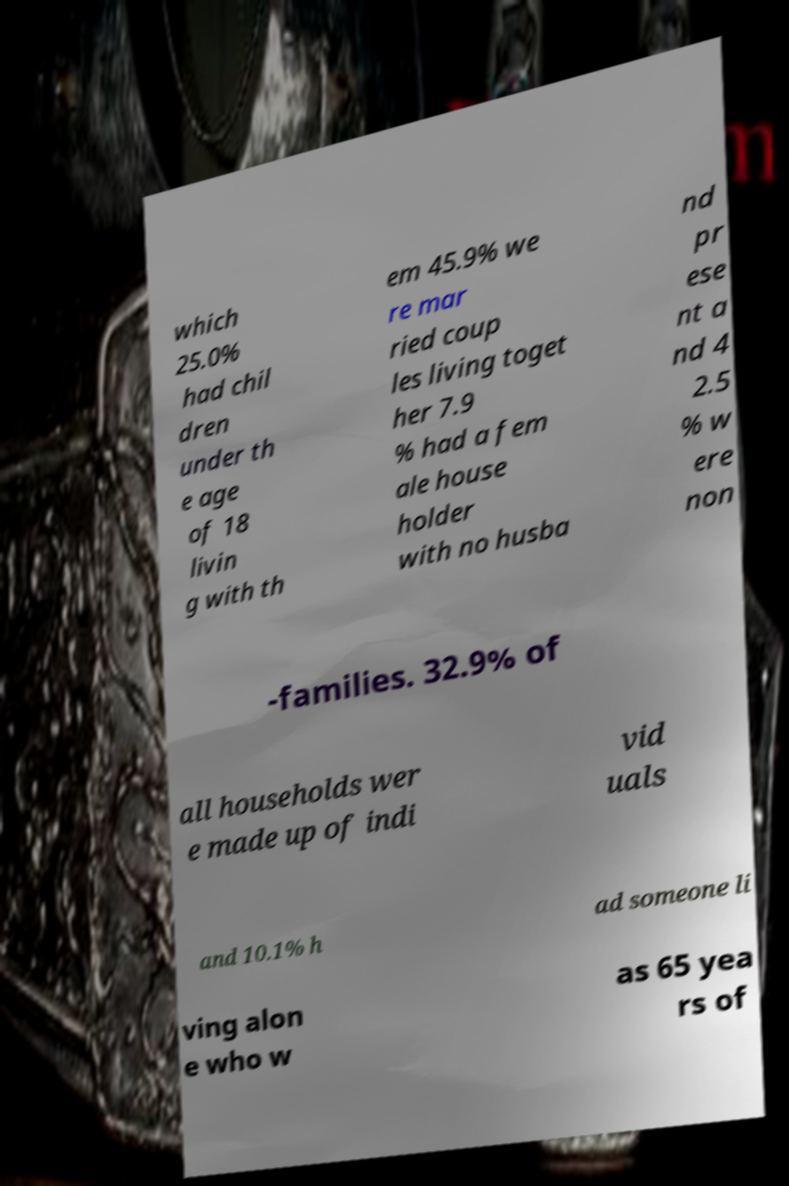There's text embedded in this image that I need extracted. Can you transcribe it verbatim? which 25.0% had chil dren under th e age of 18 livin g with th em 45.9% we re mar ried coup les living toget her 7.9 % had a fem ale house holder with no husba nd pr ese nt a nd 4 2.5 % w ere non -families. 32.9% of all households wer e made up of indi vid uals and 10.1% h ad someone li ving alon e who w as 65 yea rs of 